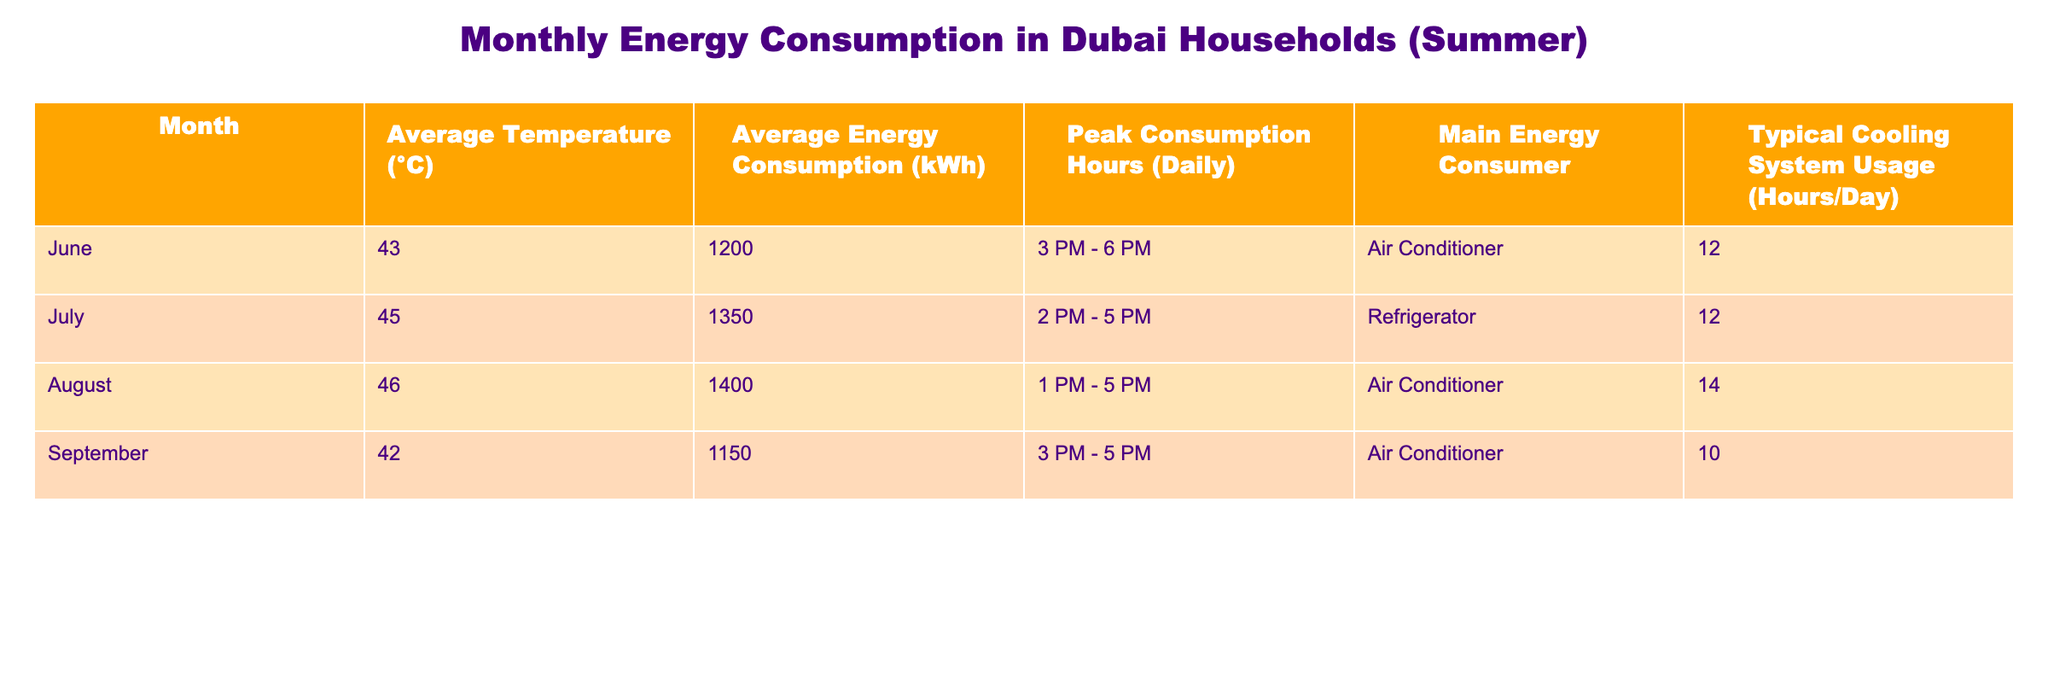What is the average energy consumption for the month of July? In the table, the average energy consumption for July is specifically listed as 1350 kWh.
Answer: 1350 kWh Which month has the highest average temperature? The table shows that August has the highest average temperature at 46 °C.
Answer: 46 °C What is the typical cooling system usage in hours per day for September? The table indicates that the typical cooling system usage for September is 10 hours per day.
Answer: 10 hours How much higher is the average energy consumption in August compared to June? In August, the average energy consumption is 1400 kWh and in June it is 1200 kWh. The difference is 1400 kWh - 1200 kWh = 200 kWh.
Answer: 200 kWh Is the main energy consumer in July an air conditioner? The table states that the main energy consumer in July is a refrigerator, not an air conditioner. Thus, the answer is no.
Answer: No How many peak consumption hours per day does the month of June have compared to September? June has 3 peak consumption hours and September has 2 peak consumption hours. The difference is 3 - 2 = 1 peak hour.
Answer: 1 peak hour What is the average energy consumption across all the months listed? Adding the average energy consumption values: (1200 + 1350 + 1400 + 1150) = 5100 kWh. Then, divide by the number of months (4): 5100 kWh / 4 = 1275 kWh.
Answer: 1275 kWh Is the average energy consumption for August higher than that of July? The average energy consumption for August (1400 kWh) is higher than that for July (1350 kWh), thus the statement is true.
Answer: Yes What is the difference in average temperatures between June and July? June has an average temperature of 43 °C, and July has an average temperature of 45 °C. The difference is 45 °C - 43 °C = 2 °C.
Answer: 2 °C 